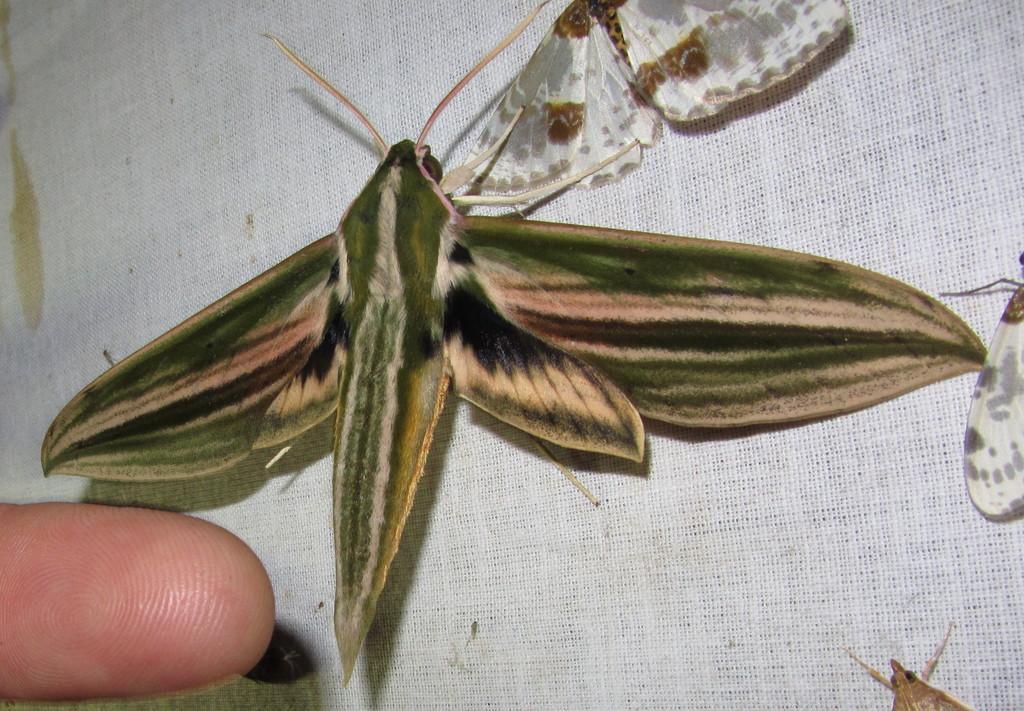Can you describe this image briefly? In the image in the center, we can see few insects on the cloth. In the bottom left side of the image, we can see one finger. 